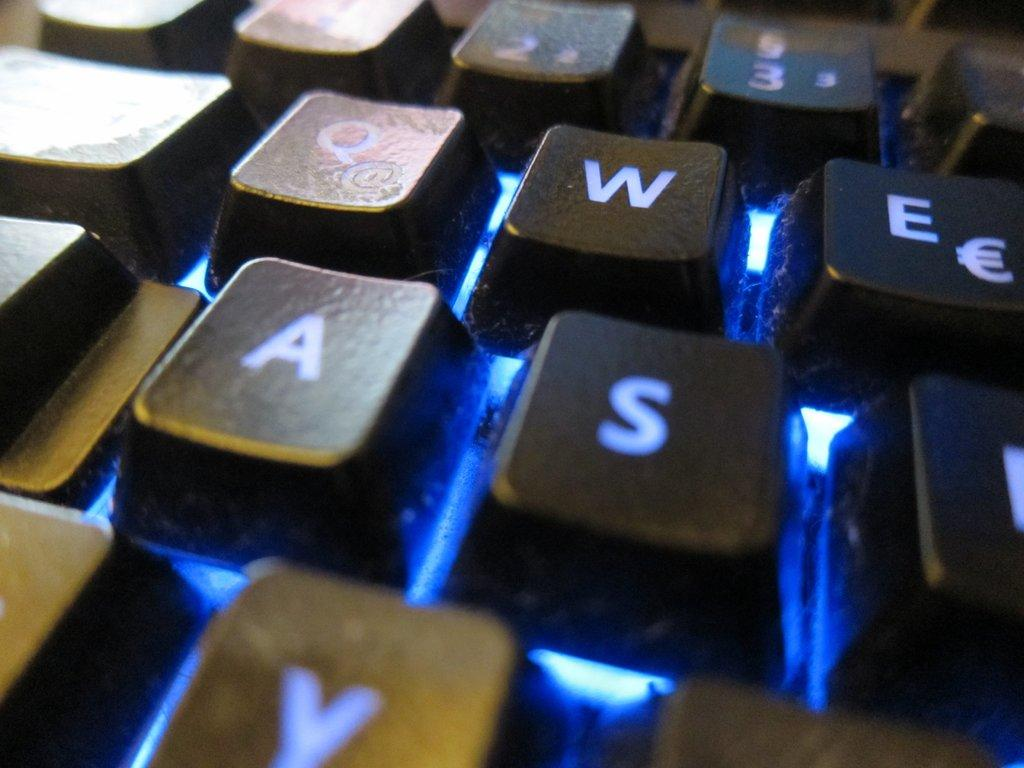<image>
Give a short and clear explanation of the subsequent image. QWE and AS section of a lit keyboard is shown up close. 